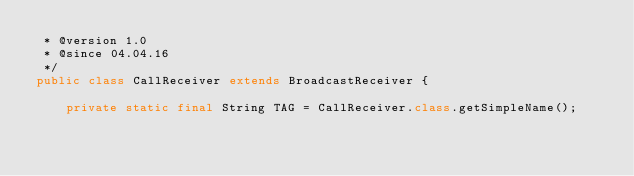Convert code to text. <code><loc_0><loc_0><loc_500><loc_500><_Java_> * @version 1.0
 * @since 04.04.16
 */
public class CallReceiver extends BroadcastReceiver {

    private static final String TAG = CallReceiver.class.getSimpleName();
</code> 